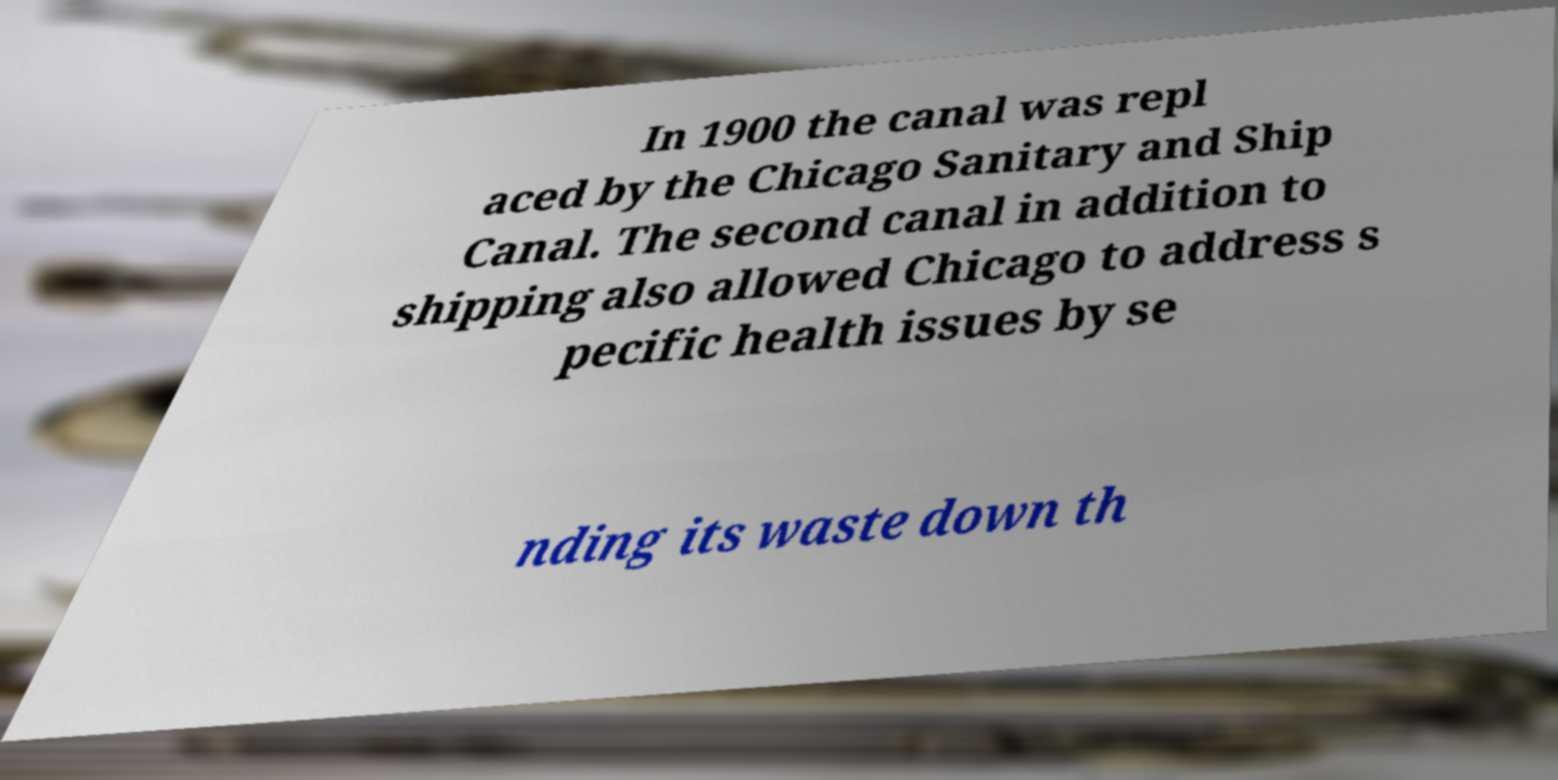What messages or text are displayed in this image? I need them in a readable, typed format. In 1900 the canal was repl aced by the Chicago Sanitary and Ship Canal. The second canal in addition to shipping also allowed Chicago to address s pecific health issues by se nding its waste down th 